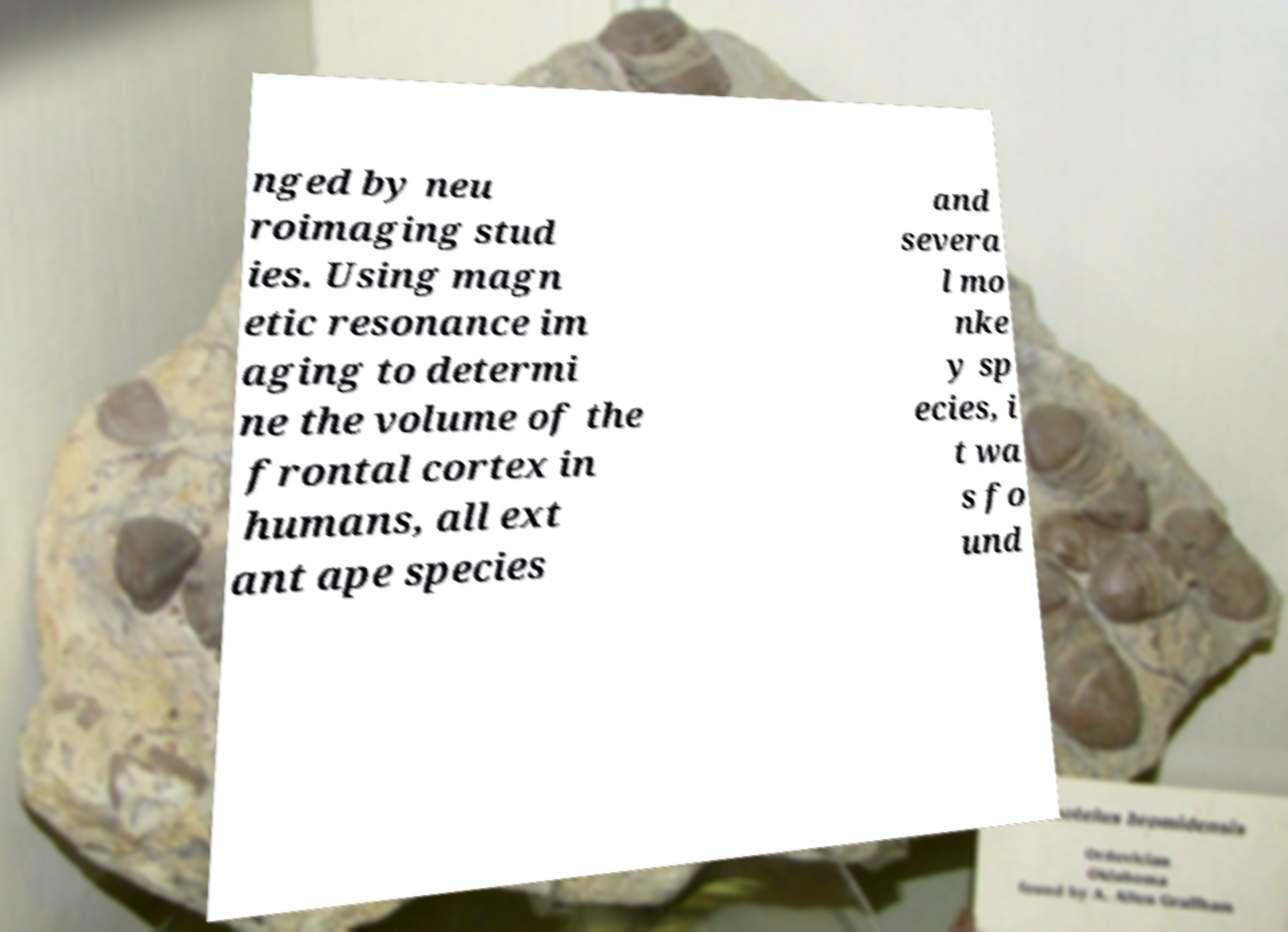There's text embedded in this image that I need extracted. Can you transcribe it verbatim? nged by neu roimaging stud ies. Using magn etic resonance im aging to determi ne the volume of the frontal cortex in humans, all ext ant ape species and severa l mo nke y sp ecies, i t wa s fo und 